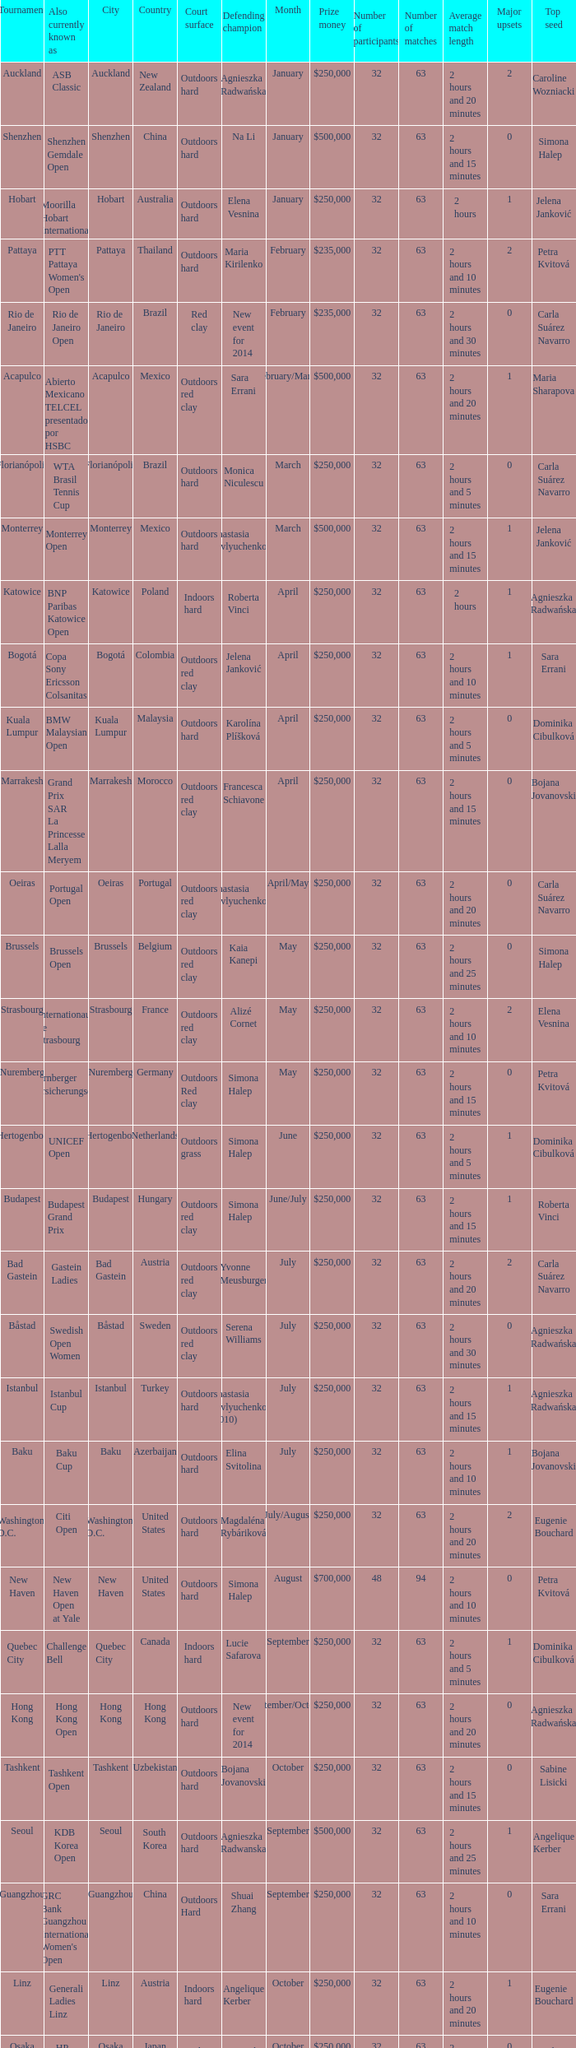How many defending champs from thailand? 1.0. 